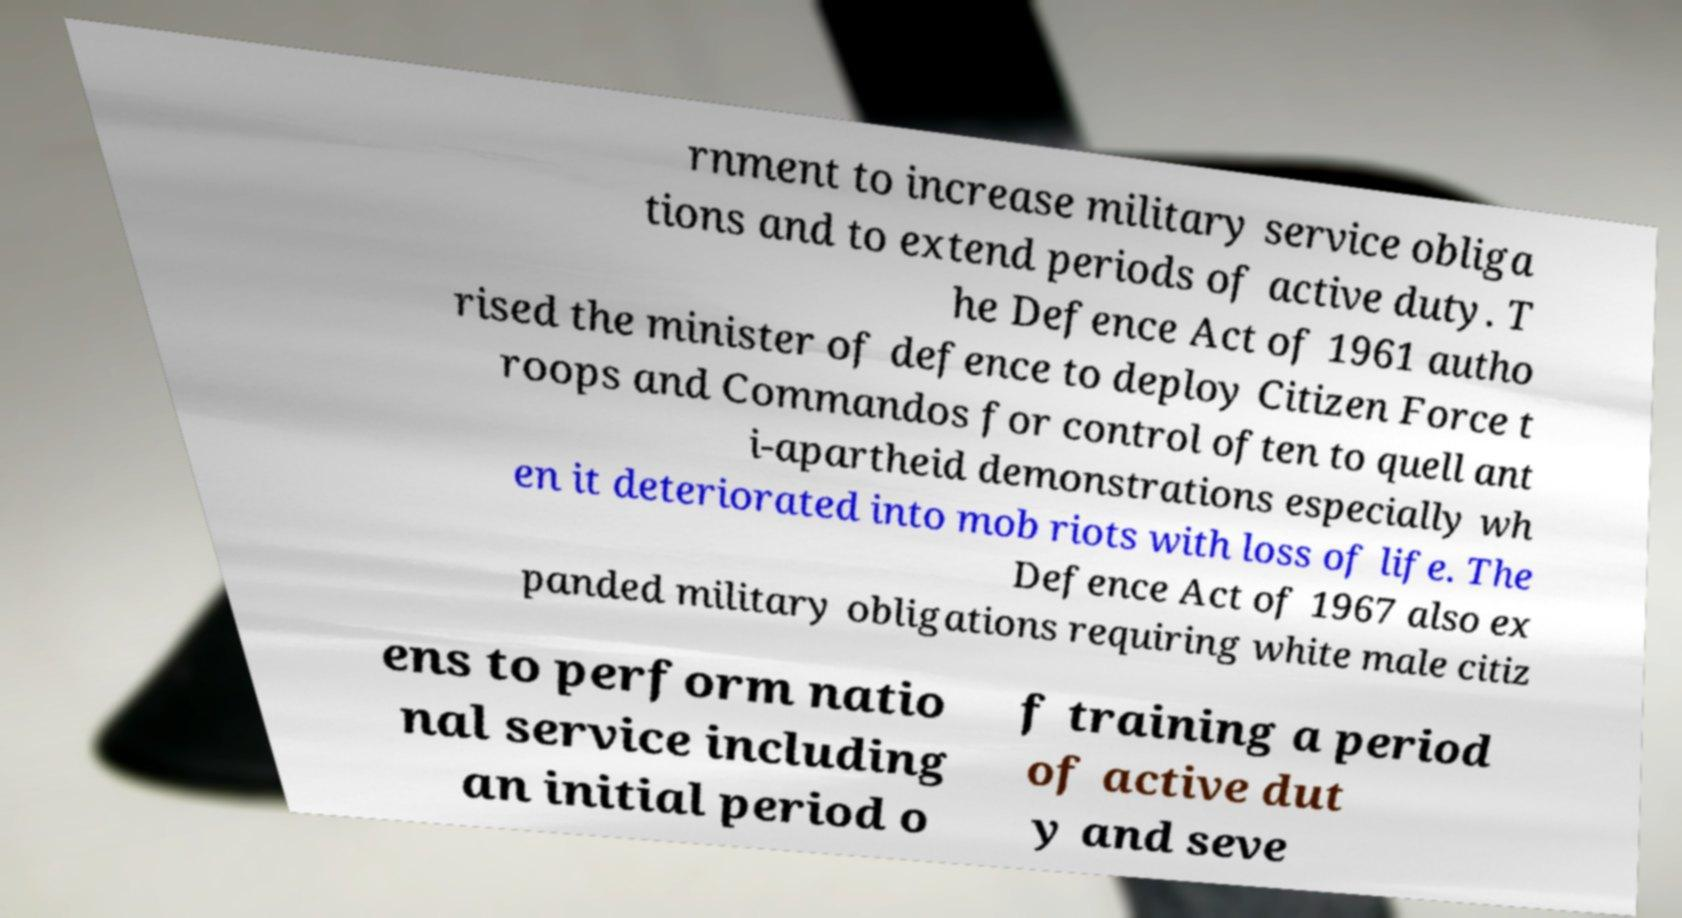Please identify and transcribe the text found in this image. rnment to increase military service obliga tions and to extend periods of active duty. T he Defence Act of 1961 autho rised the minister of defence to deploy Citizen Force t roops and Commandos for control often to quell ant i-apartheid demonstrations especially wh en it deteriorated into mob riots with loss of life. The Defence Act of 1967 also ex panded military obligations requiring white male citiz ens to perform natio nal service including an initial period o f training a period of active dut y and seve 